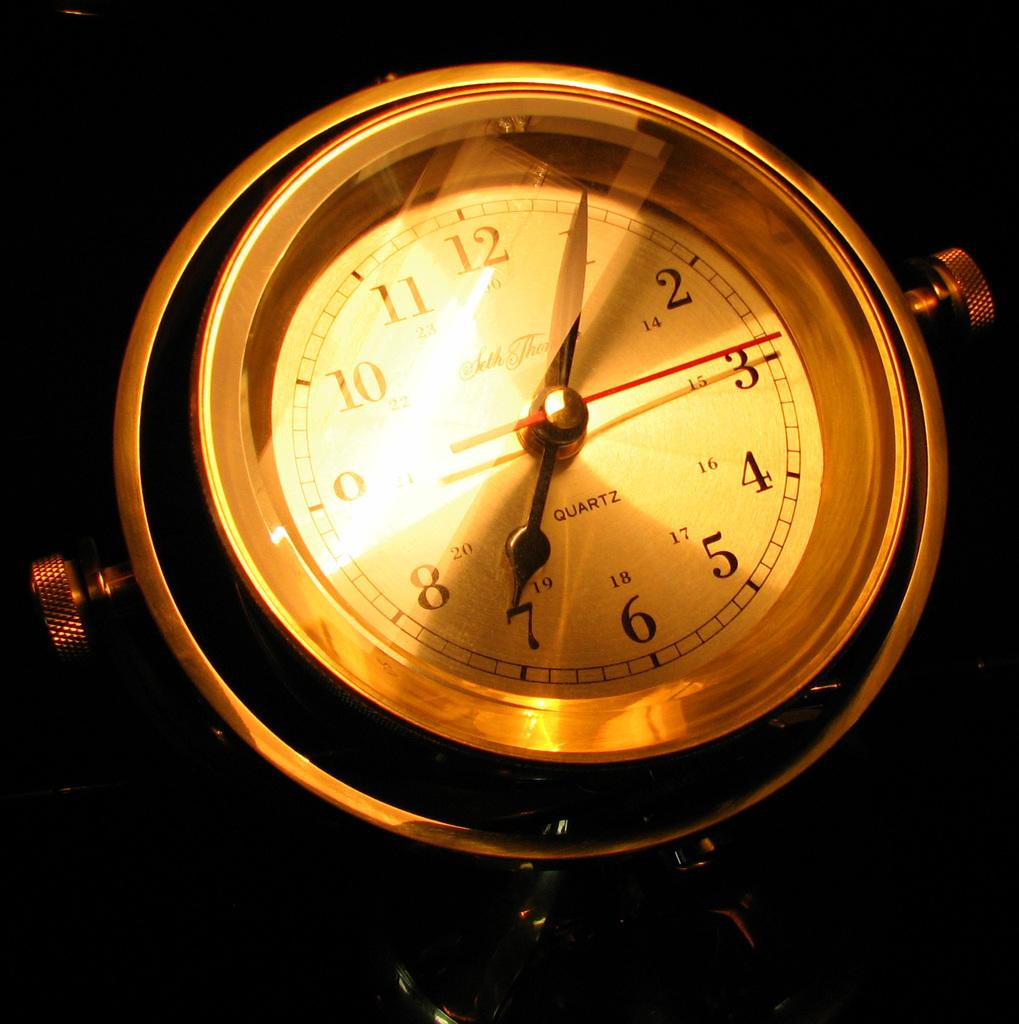<image>
Share a concise interpretation of the image provided. The clock shown in the image has a quartz movement 